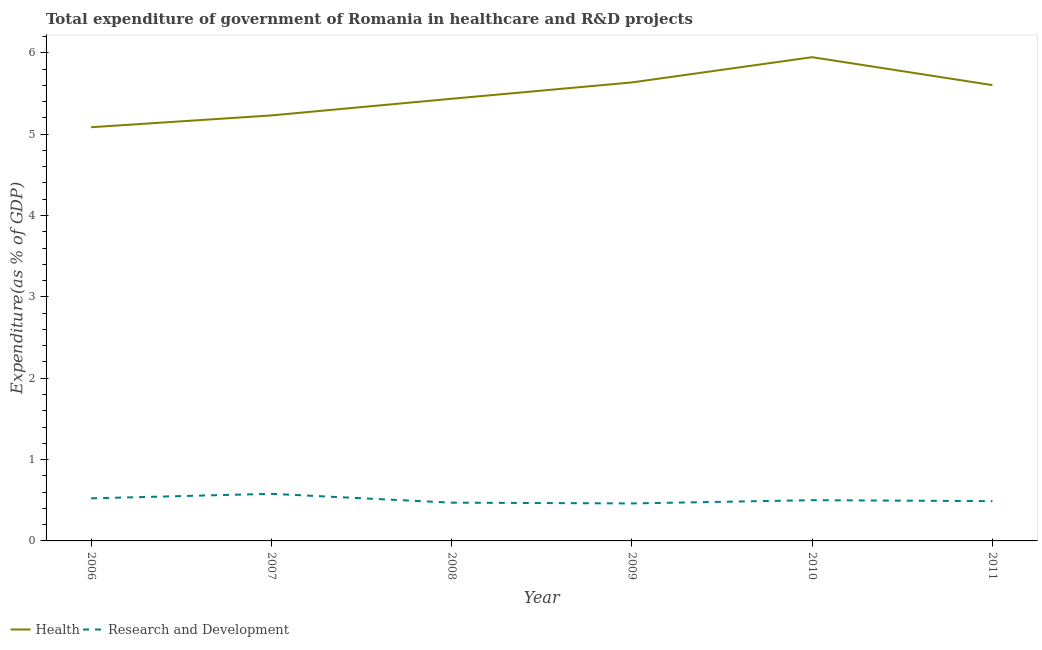How many different coloured lines are there?
Ensure brevity in your answer.  2. Is the number of lines equal to the number of legend labels?
Offer a very short reply. Yes. What is the expenditure in healthcare in 2010?
Offer a terse response. 5.95. Across all years, what is the maximum expenditure in healthcare?
Offer a terse response. 5.95. Across all years, what is the minimum expenditure in healthcare?
Your answer should be compact. 5.09. What is the total expenditure in healthcare in the graph?
Offer a terse response. 32.94. What is the difference between the expenditure in r&d in 2008 and that in 2009?
Your answer should be compact. 0.01. What is the difference between the expenditure in healthcare in 2011 and the expenditure in r&d in 2010?
Offer a terse response. 5.1. What is the average expenditure in healthcare per year?
Your answer should be compact. 5.49. In the year 2008, what is the difference between the expenditure in r&d and expenditure in healthcare?
Make the answer very short. -4.97. What is the ratio of the expenditure in r&d in 2006 to that in 2010?
Provide a short and direct response. 1.05. Is the expenditure in r&d in 2007 less than that in 2009?
Give a very brief answer. No. Is the difference between the expenditure in healthcare in 2009 and 2011 greater than the difference between the expenditure in r&d in 2009 and 2011?
Your answer should be compact. Yes. What is the difference between the highest and the second highest expenditure in r&d?
Provide a succinct answer. 0.06. What is the difference between the highest and the lowest expenditure in r&d?
Make the answer very short. 0.12. In how many years, is the expenditure in r&d greater than the average expenditure in r&d taken over all years?
Provide a short and direct response. 2. Is the sum of the expenditure in healthcare in 2008 and 2010 greater than the maximum expenditure in r&d across all years?
Keep it short and to the point. Yes. Is the expenditure in healthcare strictly greater than the expenditure in r&d over the years?
Your answer should be very brief. Yes. How many lines are there?
Provide a succinct answer. 2. How many years are there in the graph?
Your response must be concise. 6. What is the difference between two consecutive major ticks on the Y-axis?
Ensure brevity in your answer.  1. Are the values on the major ticks of Y-axis written in scientific E-notation?
Ensure brevity in your answer.  No. Where does the legend appear in the graph?
Provide a succinct answer. Bottom left. How many legend labels are there?
Provide a short and direct response. 2. What is the title of the graph?
Make the answer very short. Total expenditure of government of Romania in healthcare and R&D projects. What is the label or title of the Y-axis?
Offer a terse response. Expenditure(as % of GDP). What is the Expenditure(as % of GDP) of Health in 2006?
Provide a succinct answer. 5.09. What is the Expenditure(as % of GDP) in Research and Development in 2006?
Provide a short and direct response. 0.52. What is the Expenditure(as % of GDP) in Health in 2007?
Your answer should be compact. 5.23. What is the Expenditure(as % of GDP) in Research and Development in 2007?
Your answer should be compact. 0.58. What is the Expenditure(as % of GDP) of Health in 2008?
Offer a very short reply. 5.44. What is the Expenditure(as % of GDP) of Research and Development in 2008?
Offer a terse response. 0.47. What is the Expenditure(as % of GDP) in Health in 2009?
Offer a terse response. 5.64. What is the Expenditure(as % of GDP) in Research and Development in 2009?
Your answer should be compact. 0.46. What is the Expenditure(as % of GDP) in Health in 2010?
Ensure brevity in your answer.  5.95. What is the Expenditure(as % of GDP) of Research and Development in 2010?
Your answer should be very brief. 0.5. What is the Expenditure(as % of GDP) in Health in 2011?
Offer a terse response. 5.6. What is the Expenditure(as % of GDP) of Research and Development in 2011?
Give a very brief answer. 0.49. Across all years, what is the maximum Expenditure(as % of GDP) of Health?
Provide a short and direct response. 5.95. Across all years, what is the maximum Expenditure(as % of GDP) in Research and Development?
Ensure brevity in your answer.  0.58. Across all years, what is the minimum Expenditure(as % of GDP) in Health?
Your answer should be very brief. 5.09. Across all years, what is the minimum Expenditure(as % of GDP) of Research and Development?
Keep it short and to the point. 0.46. What is the total Expenditure(as % of GDP) of Health in the graph?
Ensure brevity in your answer.  32.94. What is the total Expenditure(as % of GDP) of Research and Development in the graph?
Make the answer very short. 3.02. What is the difference between the Expenditure(as % of GDP) of Health in 2006 and that in 2007?
Offer a very short reply. -0.15. What is the difference between the Expenditure(as % of GDP) of Research and Development in 2006 and that in 2007?
Make the answer very short. -0.06. What is the difference between the Expenditure(as % of GDP) of Health in 2006 and that in 2008?
Provide a succinct answer. -0.35. What is the difference between the Expenditure(as % of GDP) of Research and Development in 2006 and that in 2008?
Give a very brief answer. 0.05. What is the difference between the Expenditure(as % of GDP) in Health in 2006 and that in 2009?
Your response must be concise. -0.55. What is the difference between the Expenditure(as % of GDP) in Research and Development in 2006 and that in 2009?
Give a very brief answer. 0.06. What is the difference between the Expenditure(as % of GDP) of Health in 2006 and that in 2010?
Provide a succinct answer. -0.86. What is the difference between the Expenditure(as % of GDP) in Research and Development in 2006 and that in 2010?
Provide a succinct answer. 0.02. What is the difference between the Expenditure(as % of GDP) in Health in 2006 and that in 2011?
Provide a short and direct response. -0.52. What is the difference between the Expenditure(as % of GDP) of Research and Development in 2006 and that in 2011?
Give a very brief answer. 0.03. What is the difference between the Expenditure(as % of GDP) of Health in 2007 and that in 2008?
Give a very brief answer. -0.2. What is the difference between the Expenditure(as % of GDP) of Research and Development in 2007 and that in 2008?
Keep it short and to the point. 0.11. What is the difference between the Expenditure(as % of GDP) of Health in 2007 and that in 2009?
Keep it short and to the point. -0.41. What is the difference between the Expenditure(as % of GDP) of Research and Development in 2007 and that in 2009?
Provide a succinct answer. 0.12. What is the difference between the Expenditure(as % of GDP) in Health in 2007 and that in 2010?
Your answer should be very brief. -0.72. What is the difference between the Expenditure(as % of GDP) in Research and Development in 2007 and that in 2010?
Keep it short and to the point. 0.08. What is the difference between the Expenditure(as % of GDP) in Health in 2007 and that in 2011?
Provide a short and direct response. -0.37. What is the difference between the Expenditure(as % of GDP) of Research and Development in 2007 and that in 2011?
Provide a short and direct response. 0.09. What is the difference between the Expenditure(as % of GDP) of Health in 2008 and that in 2009?
Offer a terse response. -0.2. What is the difference between the Expenditure(as % of GDP) of Research and Development in 2008 and that in 2009?
Provide a succinct answer. 0.01. What is the difference between the Expenditure(as % of GDP) of Health in 2008 and that in 2010?
Offer a terse response. -0.51. What is the difference between the Expenditure(as % of GDP) of Research and Development in 2008 and that in 2010?
Offer a very short reply. -0.03. What is the difference between the Expenditure(as % of GDP) of Health in 2008 and that in 2011?
Keep it short and to the point. -0.17. What is the difference between the Expenditure(as % of GDP) of Research and Development in 2008 and that in 2011?
Keep it short and to the point. -0.02. What is the difference between the Expenditure(as % of GDP) in Health in 2009 and that in 2010?
Provide a short and direct response. -0.31. What is the difference between the Expenditure(as % of GDP) of Research and Development in 2009 and that in 2010?
Offer a very short reply. -0.04. What is the difference between the Expenditure(as % of GDP) in Health in 2009 and that in 2011?
Give a very brief answer. 0.03. What is the difference between the Expenditure(as % of GDP) in Research and Development in 2009 and that in 2011?
Your response must be concise. -0.03. What is the difference between the Expenditure(as % of GDP) of Health in 2010 and that in 2011?
Your answer should be compact. 0.34. What is the difference between the Expenditure(as % of GDP) of Research and Development in 2010 and that in 2011?
Your response must be concise. 0.01. What is the difference between the Expenditure(as % of GDP) of Health in 2006 and the Expenditure(as % of GDP) of Research and Development in 2007?
Make the answer very short. 4.51. What is the difference between the Expenditure(as % of GDP) in Health in 2006 and the Expenditure(as % of GDP) in Research and Development in 2008?
Your answer should be compact. 4.62. What is the difference between the Expenditure(as % of GDP) of Health in 2006 and the Expenditure(as % of GDP) of Research and Development in 2009?
Give a very brief answer. 4.62. What is the difference between the Expenditure(as % of GDP) of Health in 2006 and the Expenditure(as % of GDP) of Research and Development in 2010?
Offer a very short reply. 4.58. What is the difference between the Expenditure(as % of GDP) in Health in 2006 and the Expenditure(as % of GDP) in Research and Development in 2011?
Ensure brevity in your answer.  4.6. What is the difference between the Expenditure(as % of GDP) in Health in 2007 and the Expenditure(as % of GDP) in Research and Development in 2008?
Ensure brevity in your answer.  4.76. What is the difference between the Expenditure(as % of GDP) of Health in 2007 and the Expenditure(as % of GDP) of Research and Development in 2009?
Your answer should be very brief. 4.77. What is the difference between the Expenditure(as % of GDP) of Health in 2007 and the Expenditure(as % of GDP) of Research and Development in 2010?
Give a very brief answer. 4.73. What is the difference between the Expenditure(as % of GDP) of Health in 2007 and the Expenditure(as % of GDP) of Research and Development in 2011?
Offer a very short reply. 4.74. What is the difference between the Expenditure(as % of GDP) of Health in 2008 and the Expenditure(as % of GDP) of Research and Development in 2009?
Your answer should be compact. 4.97. What is the difference between the Expenditure(as % of GDP) of Health in 2008 and the Expenditure(as % of GDP) of Research and Development in 2010?
Give a very brief answer. 4.93. What is the difference between the Expenditure(as % of GDP) in Health in 2008 and the Expenditure(as % of GDP) in Research and Development in 2011?
Provide a succinct answer. 4.95. What is the difference between the Expenditure(as % of GDP) in Health in 2009 and the Expenditure(as % of GDP) in Research and Development in 2010?
Offer a terse response. 5.14. What is the difference between the Expenditure(as % of GDP) in Health in 2009 and the Expenditure(as % of GDP) in Research and Development in 2011?
Provide a short and direct response. 5.15. What is the difference between the Expenditure(as % of GDP) in Health in 2010 and the Expenditure(as % of GDP) in Research and Development in 2011?
Ensure brevity in your answer.  5.46. What is the average Expenditure(as % of GDP) of Health per year?
Your answer should be very brief. 5.49. What is the average Expenditure(as % of GDP) of Research and Development per year?
Your answer should be very brief. 0.5. In the year 2006, what is the difference between the Expenditure(as % of GDP) of Health and Expenditure(as % of GDP) of Research and Development?
Offer a terse response. 4.56. In the year 2007, what is the difference between the Expenditure(as % of GDP) of Health and Expenditure(as % of GDP) of Research and Development?
Keep it short and to the point. 4.65. In the year 2008, what is the difference between the Expenditure(as % of GDP) in Health and Expenditure(as % of GDP) in Research and Development?
Your answer should be compact. 4.96. In the year 2009, what is the difference between the Expenditure(as % of GDP) in Health and Expenditure(as % of GDP) in Research and Development?
Ensure brevity in your answer.  5.18. In the year 2010, what is the difference between the Expenditure(as % of GDP) of Health and Expenditure(as % of GDP) of Research and Development?
Make the answer very short. 5.45. In the year 2011, what is the difference between the Expenditure(as % of GDP) in Health and Expenditure(as % of GDP) in Research and Development?
Your response must be concise. 5.11. What is the ratio of the Expenditure(as % of GDP) of Health in 2006 to that in 2007?
Your answer should be compact. 0.97. What is the ratio of the Expenditure(as % of GDP) in Research and Development in 2006 to that in 2007?
Offer a terse response. 0.9. What is the ratio of the Expenditure(as % of GDP) in Health in 2006 to that in 2008?
Offer a terse response. 0.94. What is the ratio of the Expenditure(as % of GDP) in Research and Development in 2006 to that in 2008?
Offer a terse response. 1.11. What is the ratio of the Expenditure(as % of GDP) in Health in 2006 to that in 2009?
Offer a terse response. 0.9. What is the ratio of the Expenditure(as % of GDP) in Research and Development in 2006 to that in 2009?
Offer a very short reply. 1.14. What is the ratio of the Expenditure(as % of GDP) in Health in 2006 to that in 2010?
Ensure brevity in your answer.  0.86. What is the ratio of the Expenditure(as % of GDP) in Research and Development in 2006 to that in 2010?
Offer a terse response. 1.05. What is the ratio of the Expenditure(as % of GDP) of Health in 2006 to that in 2011?
Offer a very short reply. 0.91. What is the ratio of the Expenditure(as % of GDP) of Research and Development in 2006 to that in 2011?
Your answer should be very brief. 1.07. What is the ratio of the Expenditure(as % of GDP) in Health in 2007 to that in 2008?
Keep it short and to the point. 0.96. What is the ratio of the Expenditure(as % of GDP) in Research and Development in 2007 to that in 2008?
Your response must be concise. 1.23. What is the ratio of the Expenditure(as % of GDP) in Health in 2007 to that in 2009?
Make the answer very short. 0.93. What is the ratio of the Expenditure(as % of GDP) in Research and Development in 2007 to that in 2009?
Provide a short and direct response. 1.26. What is the ratio of the Expenditure(as % of GDP) in Health in 2007 to that in 2010?
Give a very brief answer. 0.88. What is the ratio of the Expenditure(as % of GDP) in Research and Development in 2007 to that in 2010?
Make the answer very short. 1.16. What is the ratio of the Expenditure(as % of GDP) of Health in 2007 to that in 2011?
Offer a terse response. 0.93. What is the ratio of the Expenditure(as % of GDP) in Research and Development in 2007 to that in 2011?
Your response must be concise. 1.18. What is the ratio of the Expenditure(as % of GDP) of Health in 2008 to that in 2009?
Your answer should be compact. 0.96. What is the ratio of the Expenditure(as % of GDP) in Research and Development in 2008 to that in 2009?
Offer a terse response. 1.02. What is the ratio of the Expenditure(as % of GDP) in Health in 2008 to that in 2010?
Provide a short and direct response. 0.91. What is the ratio of the Expenditure(as % of GDP) in Research and Development in 2008 to that in 2010?
Keep it short and to the point. 0.94. What is the ratio of the Expenditure(as % of GDP) of Health in 2008 to that in 2011?
Ensure brevity in your answer.  0.97. What is the ratio of the Expenditure(as % of GDP) in Research and Development in 2008 to that in 2011?
Provide a succinct answer. 0.96. What is the ratio of the Expenditure(as % of GDP) in Health in 2009 to that in 2010?
Make the answer very short. 0.95. What is the ratio of the Expenditure(as % of GDP) of Research and Development in 2009 to that in 2010?
Offer a very short reply. 0.92. What is the ratio of the Expenditure(as % of GDP) in Health in 2009 to that in 2011?
Your answer should be compact. 1.01. What is the ratio of the Expenditure(as % of GDP) of Research and Development in 2009 to that in 2011?
Provide a succinct answer. 0.94. What is the ratio of the Expenditure(as % of GDP) in Health in 2010 to that in 2011?
Ensure brevity in your answer.  1.06. What is the ratio of the Expenditure(as % of GDP) of Research and Development in 2010 to that in 2011?
Offer a very short reply. 1.02. What is the difference between the highest and the second highest Expenditure(as % of GDP) of Health?
Make the answer very short. 0.31. What is the difference between the highest and the second highest Expenditure(as % of GDP) in Research and Development?
Your response must be concise. 0.06. What is the difference between the highest and the lowest Expenditure(as % of GDP) in Health?
Offer a very short reply. 0.86. What is the difference between the highest and the lowest Expenditure(as % of GDP) of Research and Development?
Keep it short and to the point. 0.12. 